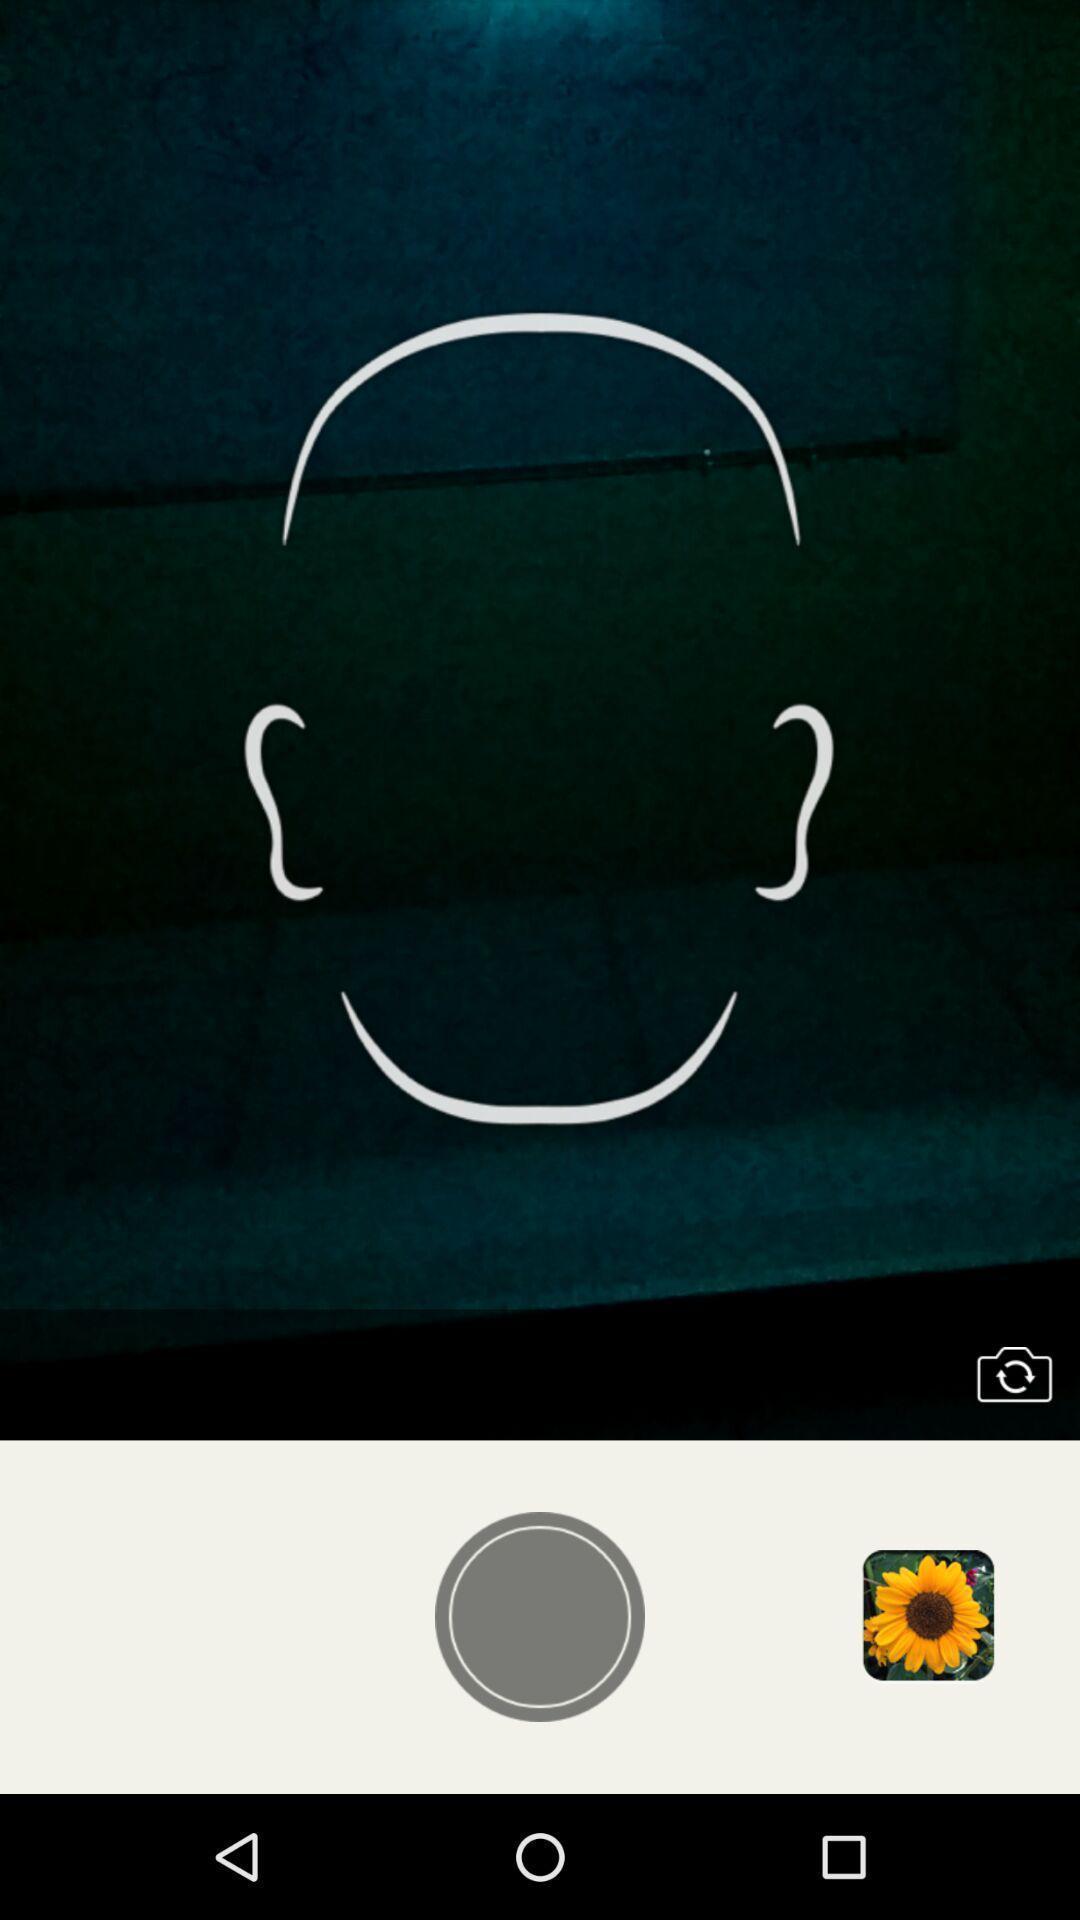Give me a narrative description of this picture. Video recorder page of face fat app. 